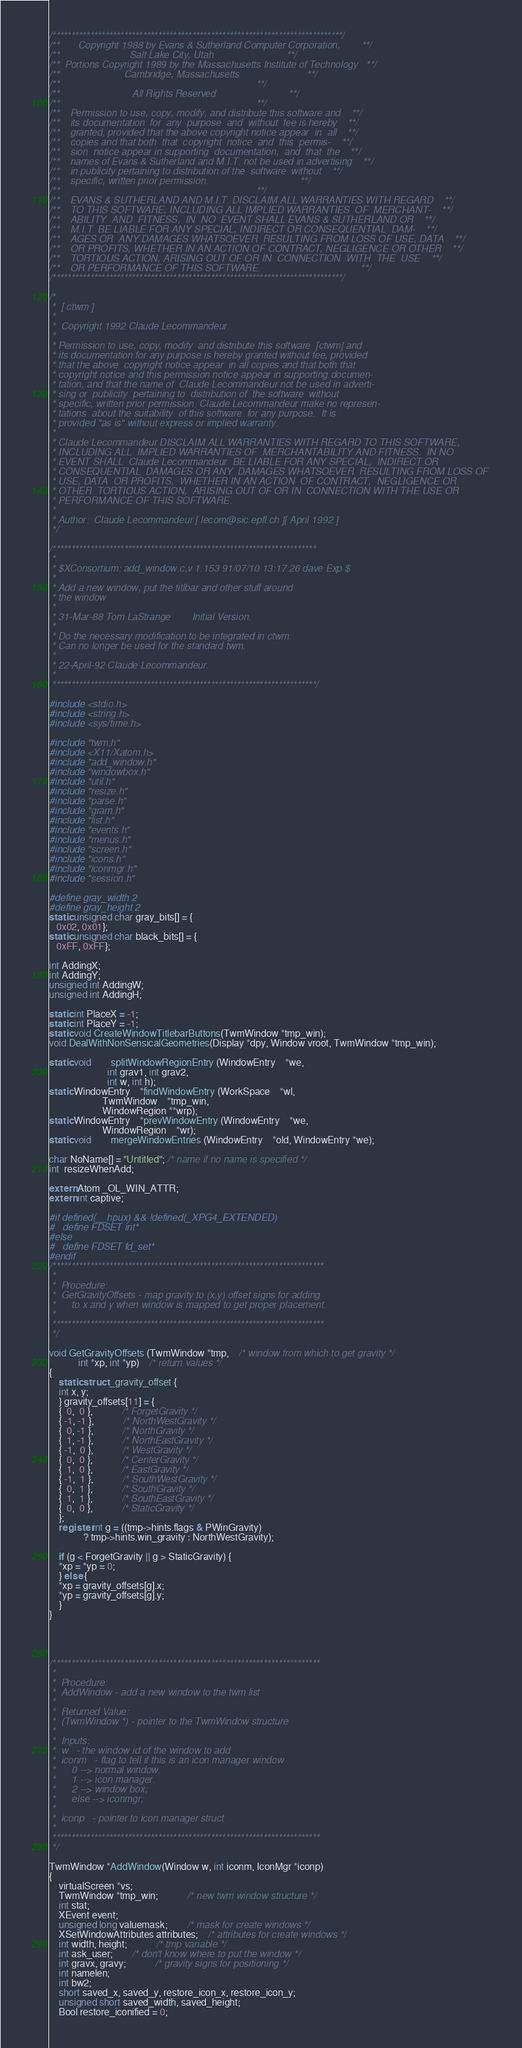<code> <loc_0><loc_0><loc_500><loc_500><_C_>/*****************************************************************************/
/**       Copyright 1988 by Evans & Sutherland Computer Corporation,        **/
/**                          Salt Lake City, Utah                           **/
/**  Portions Copyright 1989 by the Massachusetts Institute of Technology   **/
/**                        Cambridge, Massachusetts                         **/
/**                                                                         **/
/**                           All Rights Reserved                           **/
/**                                                                         **/
/**    Permission to use, copy, modify, and distribute this software and    **/
/**    its documentation  for  any  purpose  and  without  fee is hereby    **/
/**    granted, provided that the above copyright notice appear  in  all    **/
/**    copies and that both  that  copyright  notice  and  this  permis-    **/
/**    sion  notice appear in supporting  documentation,  and  that  the    **/
/**    names of Evans & Sutherland and M.I.T. not be used in advertising    **/
/**    in publicity pertaining to distribution of the  software  without    **/
/**    specific, written prior permission.                                  **/
/**                                                                         **/
/**    EVANS & SUTHERLAND AND M.I.T. DISCLAIM ALL WARRANTIES WITH REGARD    **/
/**    TO THIS SOFTWARE, INCLUDING ALL IMPLIED WARRANTIES  OF  MERCHANT-    **/
/**    ABILITY  AND  FITNESS,  IN  NO  EVENT SHALL EVANS & SUTHERLAND OR    **/
/**    M.I.T. BE LIABLE FOR ANY SPECIAL, INDIRECT OR CONSEQUENTIAL  DAM-    **/
/**    AGES OR  ANY DAMAGES WHATSOEVER  RESULTING FROM LOSS OF USE, DATA    **/
/**    OR PROFITS, WHETHER IN AN ACTION OF CONTRACT, NEGLIGENCE OR OTHER    **/
/**    TORTIOUS ACTION, ARISING OUT OF OR IN  CONNECTION  WITH  THE  USE    **/
/**    OR PERFORMANCE OF THIS SOFTWARE.                                     **/
/*****************************************************************************/

/* 
 *  [ ctwm ]
 *
 *  Copyright 1992 Claude Lecommandeur.
 *            
 * Permission to use, copy, modify  and distribute this software  [ctwm] and
 * its documentation for any purpose is hereby granted without fee, provided
 * that the above  copyright notice appear  in all copies and that both that
 * copyright notice and this permission notice appear in supporting documen-
 * tation, and that the name of  Claude Lecommandeur not be used in adverti-
 * sing or  publicity  pertaining to  distribution of  the software  without
 * specific, written prior permission. Claude Lecommandeur make no represen-
 * tations  about the suitability  of this software  for any purpose.  It is
 * provided "as is" without express or implied warranty.
 *
 * Claude Lecommandeur DISCLAIM ALL WARRANTIES WITH REGARD TO THIS SOFTWARE,
 * INCLUDING ALL  IMPLIED WARRANTIES OF  MERCHANTABILITY AND FITNESS.  IN NO
 * EVENT SHALL  Claude Lecommandeur  BE LIABLE FOR ANY SPECIAL,  INDIRECT OR
 * CONSEQUENTIAL  DAMAGES OR ANY  DAMAGES WHATSOEVER  RESULTING FROM LOSS OF
 * USE, DATA  OR PROFITS,  WHETHER IN AN ACTION  OF CONTRACT,  NEGLIGENCE OR
 * OTHER  TORTIOUS ACTION,  ARISING OUT OF OR IN  CONNECTION WITH THE USE OR
 * PERFORMANCE OF THIS SOFTWARE.
 *
 * Author:  Claude Lecommandeur [ lecom@sic.epfl.ch ][ April 1992 ]
 */

/**********************************************************************
 *
 * $XConsortium: add_window.c,v 1.153 91/07/10 13:17:26 dave Exp $
 *
 * Add a new window, put the titlbar and other stuff around
 * the window
 *
 * 31-Mar-88 Tom LaStrange        Initial Version.
 *
 * Do the necessary modification to be integrated in ctwm.
 * Can no longer be used for the standard twm.
 *
 * 22-April-92 Claude Lecommandeur.
 *
 **********************************************************************/

#include <stdio.h>
#include <string.h>
#include <sys/time.h>

#include "twm.h"
#include <X11/Xatom.h>
#include "add_window.h"
#include "windowbox.h"
#include "util.h"
#include "resize.h"
#include "parse.h"
#include "gram.h"
#include "list.h"
#include "events.h"
#include "menus.h"
#include "screen.h"
#include "icons.h"
#include "iconmgr.h"
#include "session.h"

#define gray_width 2
#define gray_height 2
static unsigned char gray_bits[] = {
   0x02, 0x01};
static unsigned char black_bits[] = {
   0xFF, 0xFF};

int AddingX;
int AddingY;
unsigned int AddingW;
unsigned int AddingH;

static int PlaceX = -1;
static int PlaceY = -1;
static void CreateWindowTitlebarButtons(TwmWindow *tmp_win);
void DealWithNonSensicalGeometries(Display *dpy, Window vroot, TwmWindow *tmp_win);

static void		splitWindowRegionEntry (WindowEntry	*we,
						int grav1, int grav2,
						int w, int h);
static WindowEntry	*findWindowEntry (WorkSpace    *wl,
					  TwmWindow    *tmp_win,
					  WindowRegion **wrp);
static WindowEntry	*prevWindowEntry (WindowEntry	*we,
					  WindowRegion	*wr);
static void		mergeWindowEntries (WindowEntry	*old, WindowEntry *we);

char NoName[] = "Untitled"; /* name if no name is specified */
int  resizeWhenAdd;

extern Atom _OL_WIN_ATTR;
extern int captive;

#if defined(__hpux) && !defined(_XPG4_EXTENDED)
#   define FDSET int*
#else
#   define FDSET fd_set*
#endif
/************************************************************************
 *
 *  Procedure:
 *	GetGravityOffsets - map gravity to (x,y) offset signs for adding
 *		to x and y when window is mapped to get proper placement.
 * 
 ************************************************************************
 */

void GetGravityOffsets (TwmWindow *tmp,	/* window from which to get gravity */
			int *xp, int *yp)	/* return values */
{
    static struct _gravity_offset {
	int x, y;
    } gravity_offsets[11] = {
	{  0,  0 },			/* ForgetGravity */
	{ -1, -1 },			/* NorthWestGravity */
	{  0, -1 },			/* NorthGravity */
	{  1, -1 },			/* NorthEastGravity */
	{ -1,  0 },			/* WestGravity */
	{  0,  0 },			/* CenterGravity */
	{  1,  0 },			/* EastGravity */
	{ -1,  1 },			/* SouthWestGravity */
	{  0,  1 },			/* SouthGravity */
	{  1,  1 },			/* SouthEastGravity */
	{  0,  0 },			/* StaticGravity */
    };
    register int g = ((tmp->hints.flags & PWinGravity) 
		      ? tmp->hints.win_gravity : NorthWestGravity);

    if (g < ForgetGravity || g > StaticGravity) {
	*xp = *yp = 0;
    } else {
	*xp = gravity_offsets[g].x;
	*yp = gravity_offsets[g].y;
    }
}




/***********************************************************************
 *
 *  Procedure:
 *	AddWindow - add a new window to the twm list
 *
 *  Returned Value:
 *	(TwmWindow *) - pointer to the TwmWindow structure
 *
 *  Inputs:
 *	w	- the window id of the window to add
 *	iconm	- flag to tell if this is an icon manager window
 *		0 --> normal window.
 *		1 --> icon manager.
 *		2 --> window box;
 *		else --> iconmgr;
 *
 *	iconp	- pointer to icon manager struct
 *
 ***********************************************************************
 */

TwmWindow *AddWindow(Window w, int iconm, IconMgr *iconp)
{
    virtualScreen *vs;
    TwmWindow *tmp_win;			/* new twm window structure */
    int stat;
    XEvent event;
    unsigned long valuemask;		/* mask for create windows */
    XSetWindowAttributes attributes;	/* attributes for create windows */
    int width, height;			/* tmp variable */
    int ask_user;		/* don't know where to put the window */
    int gravx, gravy;			/* gravity signs for positioning */
    int namelen;
    int bw2;
    short saved_x, saved_y, restore_icon_x, restore_icon_y;
    unsigned short saved_width, saved_height;
    Bool restore_iconified = 0;</code> 